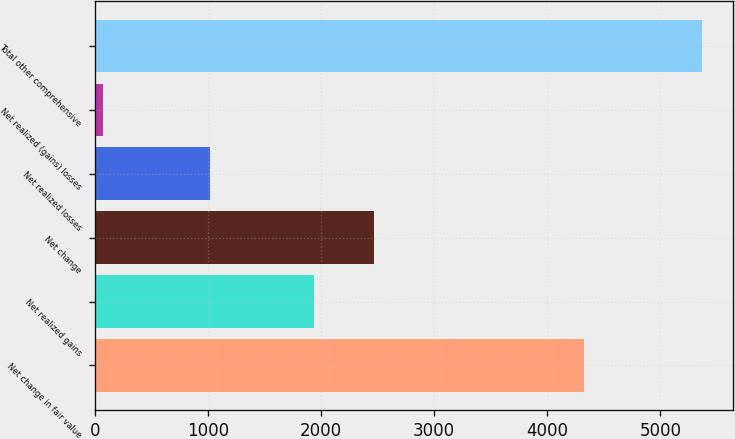Convert chart. <chart><loc_0><loc_0><loc_500><loc_500><bar_chart><fcel>Net change in fair value<fcel>Net realized gains<fcel>Net change<fcel>Net realized losses<fcel>Net realized (gains) losses<fcel>Total other comprehensive<nl><fcel>4323<fcel>1937<fcel>2466.7<fcel>1018<fcel>74<fcel>5371<nl></chart> 